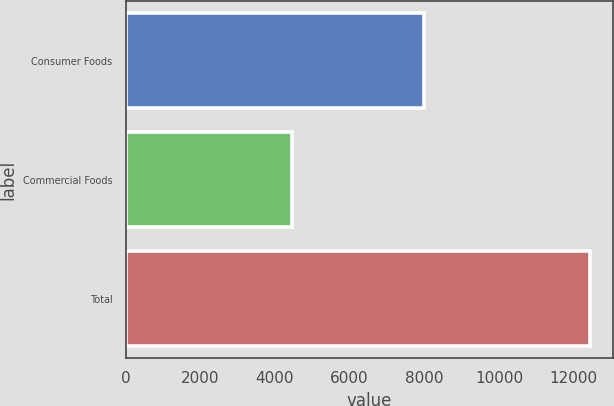Convert chart to OTSL. <chart><loc_0><loc_0><loc_500><loc_500><bar_chart><fcel>Consumer Foods<fcel>Commercial Foods<fcel>Total<nl><fcel>7979<fcel>4447<fcel>12426<nl></chart> 